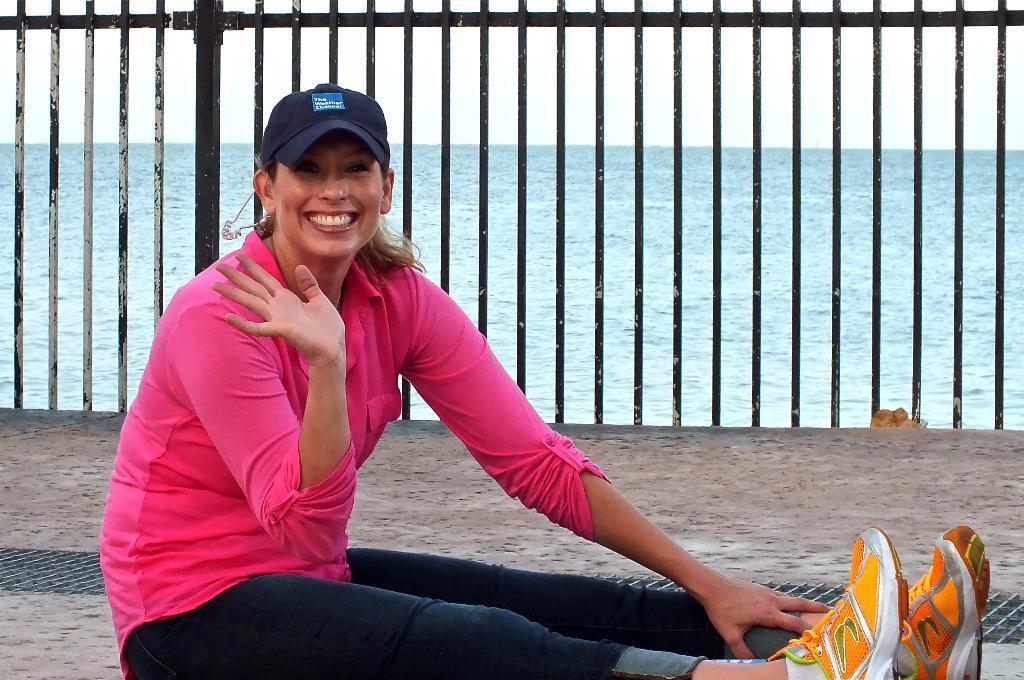Can you describe this image briefly? In this picture we can see a woman, she is sitting and she is smiling, behind her we can see few metal rods and water. 